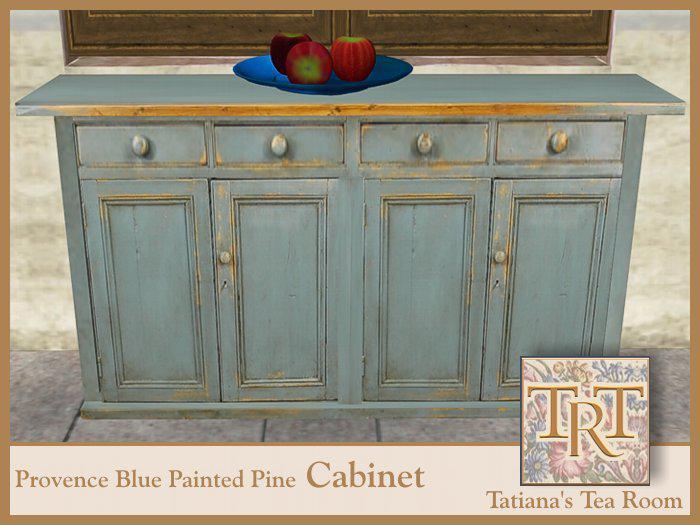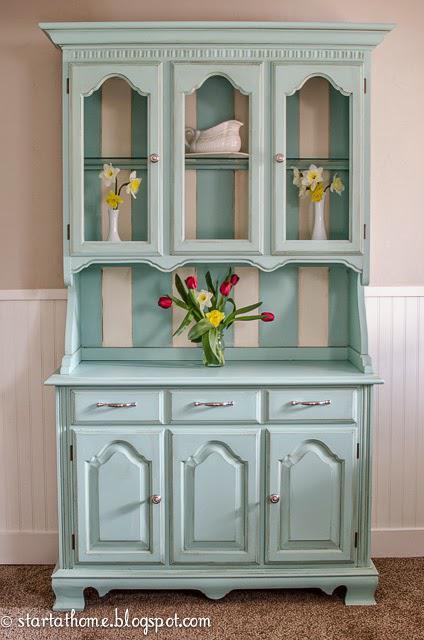The first image is the image on the left, the second image is the image on the right. Assess this claim about the two images: "A blue china cabinet sits against a wall with beadboard on the lower half.". Correct or not? Answer yes or no. Yes. The first image is the image on the left, the second image is the image on the right. For the images displayed, is the sentence "There is a flower in a vase." factually correct? Answer yes or no. Yes. 